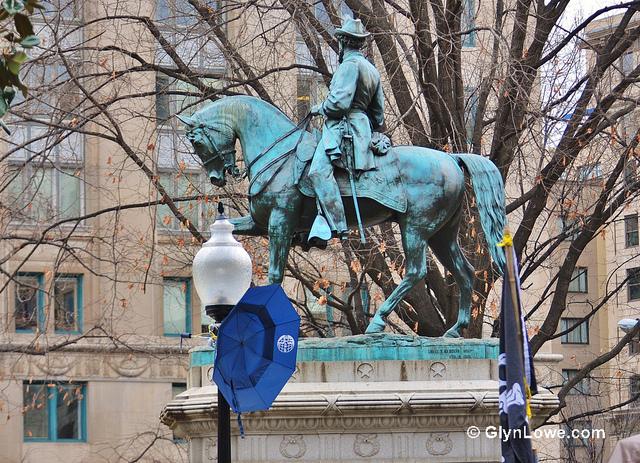Is the horse real?
Give a very brief answer. No. What color is the umbrella?
Short answer required. Blue. What city is this?
Answer briefly. Boston. 